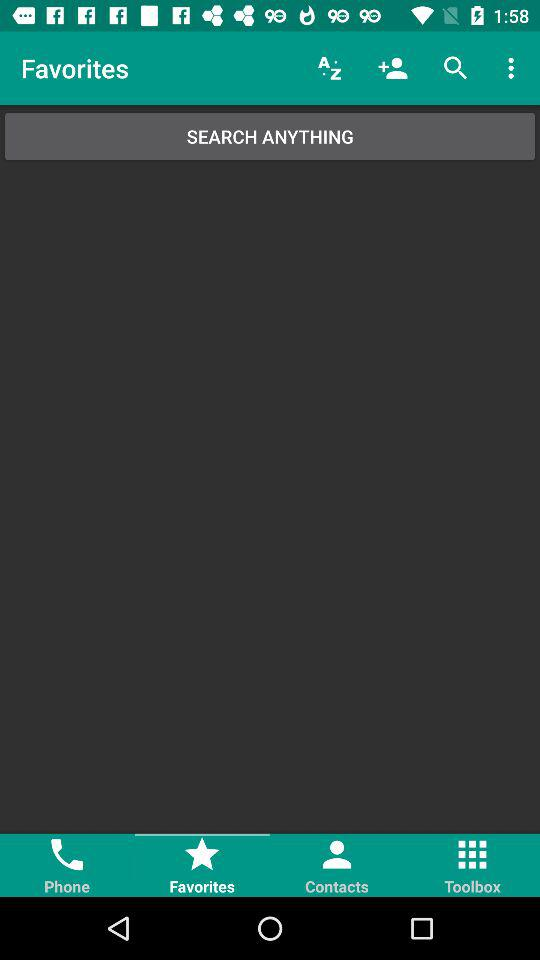What is the selected tab? The selected tab is "Favorites". 